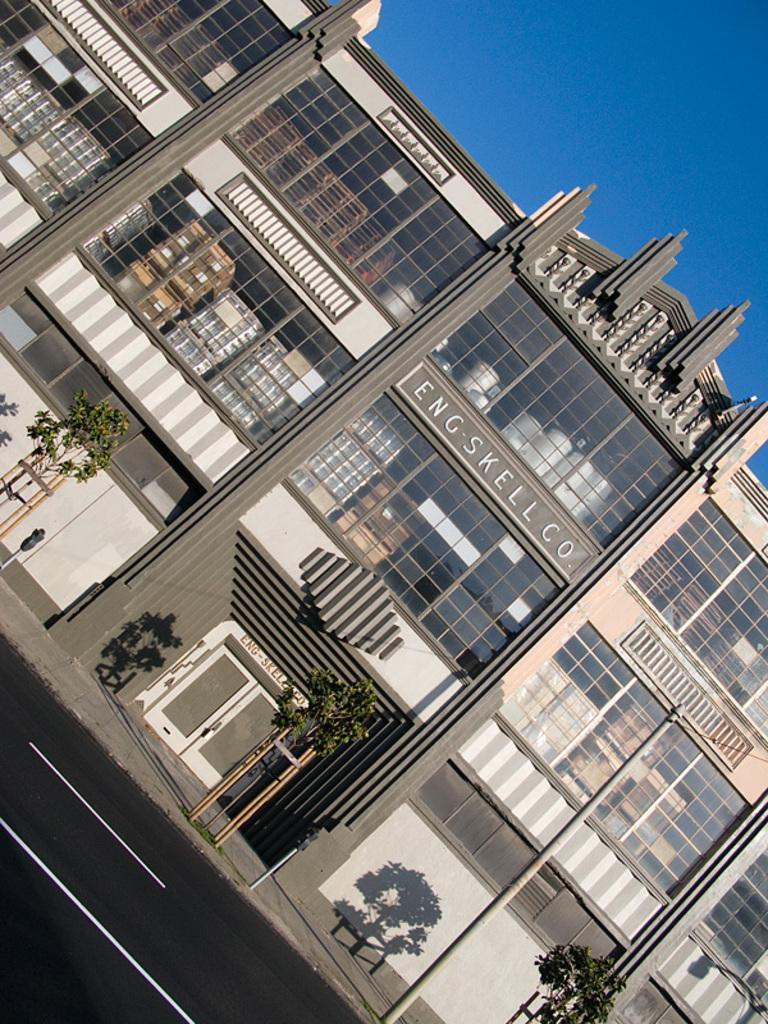What type of structure is present in the image? There is a building in the image. What is located in front of the building? There are small trees in front of the building. What can be seen running through the image? There is a road in the image. What is visible in the background of the image? The sky is visible in the background of the image. How many legs can be seen on the celery in the image? There is no celery present in the image, and therefore no legs can be seen on it. 